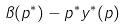<formula> <loc_0><loc_0><loc_500><loc_500>\pi ( p ^ { * } ) - p ^ { * } y ^ { * } ( p )</formula> 